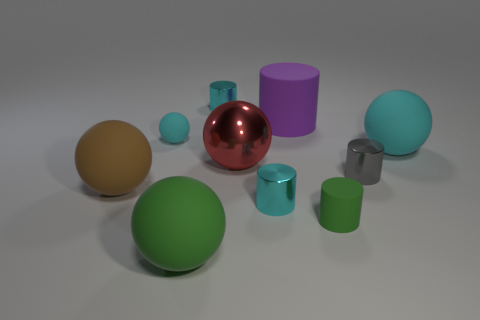Which object in the image looks the largest? The green ball situated at the forefront of the image appears to be the largest object due to its placement and perspective within the scene. 